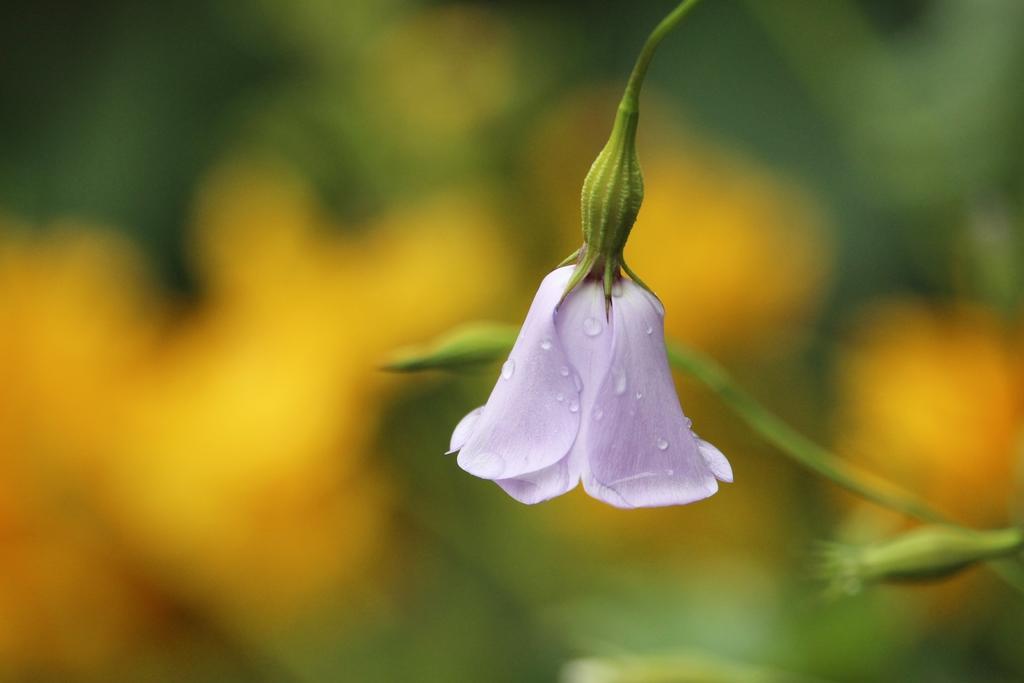Can you describe this image briefly? We can see flower and stem. In the background it is blur. 